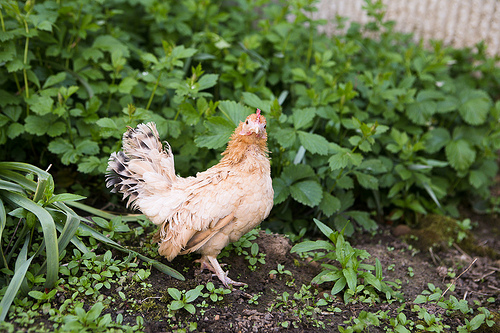<image>
Is there a hen behind the grass? No. The hen is not behind the grass. From this viewpoint, the hen appears to be positioned elsewhere in the scene. Is the hen above the land? No. The hen is not positioned above the land. The vertical arrangement shows a different relationship. 